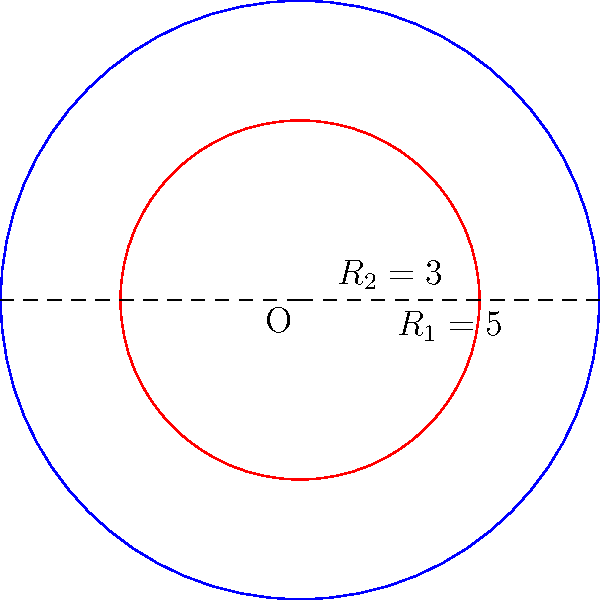In an experiment analyzing circular wave propagation, you encounter two concentric circles with radii $R_1 = 5$ cm and $R_2 = 3$ cm. Calculate the area of the region between these two circles, which represents the area affected by the interference of two waves. To find the area between two concentric circles, we need to:

1. Calculate the area of the larger circle (radius $R_1$):
   $$A_1 = \pi R_1^2 = \pi (5\text{ cm})^2 = 25\pi \text{ cm}^2$$

2. Calculate the area of the smaller circle (radius $R_2$):
   $$A_2 = \pi R_2^2 = \pi (3\text{ cm})^2 = 9\pi \text{ cm}^2$$

3. Subtract the area of the smaller circle from the larger circle:
   $$A_{\text{between}} = A_1 - A_2 = 25\pi \text{ cm}^2 - 9\pi \text{ cm}^2 = 16\pi \text{ cm}^2$$

Therefore, the area between the two concentric circles is $16\pi \text{ cm}^2$.
Answer: $16\pi \text{ cm}^2$ 